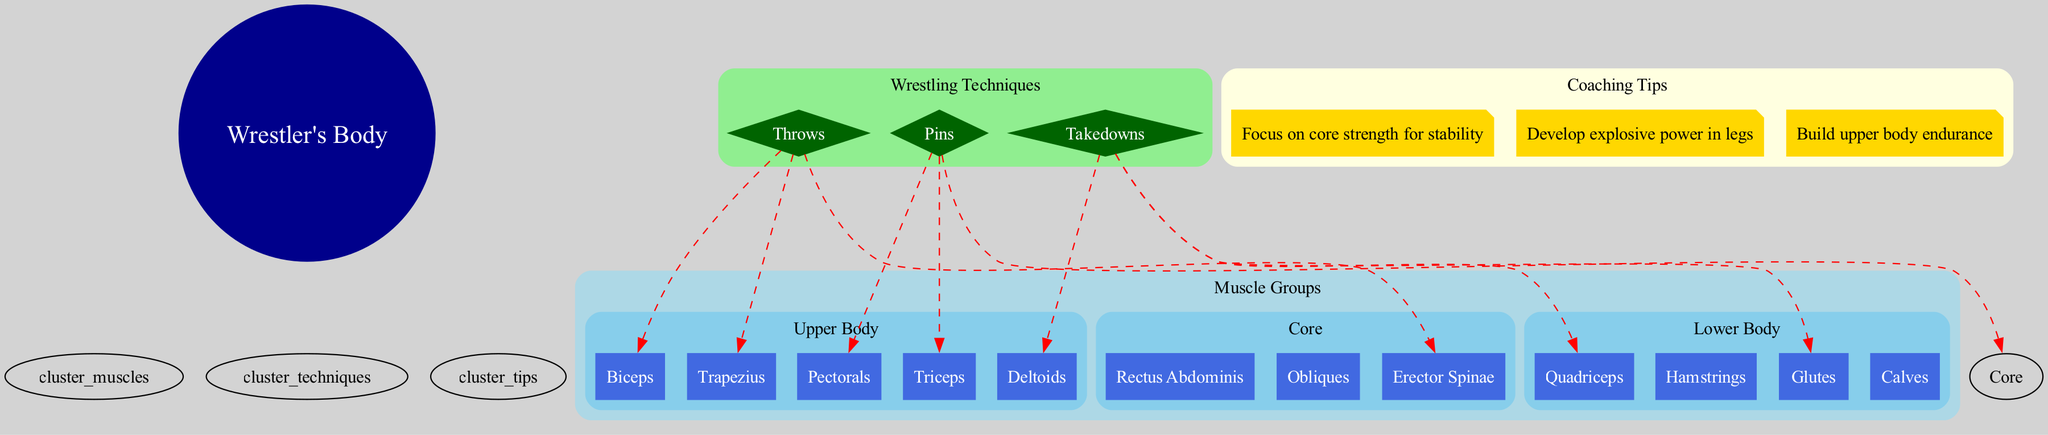What is the central node of the diagram? The central node is labeled "Wrestler's Body," which represents the main subject of the diagram.
Answer: Wrestler's Body How many muscle groups are shown in the diagram? There are three muscle groups listed: Upper Body, Core, and Lower Body. By counting them, the total is determined to be three.
Answer: 3 Which muscles are primary for the "Takedowns" technique? The primary muscles listed for "Takedowns" are Quadriceps, Glutes, and Deltoids.
Answer: Quadriceps, Glutes, Deltoids What colors are used for the muscle group nodes? The muscle group nodes are colored skyblue, providing a clear distinction among different groups.
Answer: Skyblue Which muscle is associated with both "Pins" and "Core"? The muscle associated with both "Pins" and "Core" is the "Core," as it's specifically stated as a primary muscle for the Pins technique.
Answer: Core What coaching tip emphasizes leg strength? The coaching tip that emphasizes leg strength is "Develop explosive power in legs," focusing on the importance of leg muscles for wrestling.
Answer: Develop explosive power in legs Which muscle is used primarily in the "Throws" technique? The primary muscles for the "Throws" technique include Trapezius, Biceps, and Erector Spinae, so any of these can be used as an answer.
Answer: Trapezius How many techniques are listed in the diagram? There are three techniques present in the diagram: Takedowns, Pins, and Throws. Counting them leads to a total of three techniques.
Answer: 3 Which muscle group does the "Rectus Abdominis" belong to? The "Rectus Abdominis" belongs to the Core muscle group, explicitly categorized under Core in the diagram.
Answer: Core 